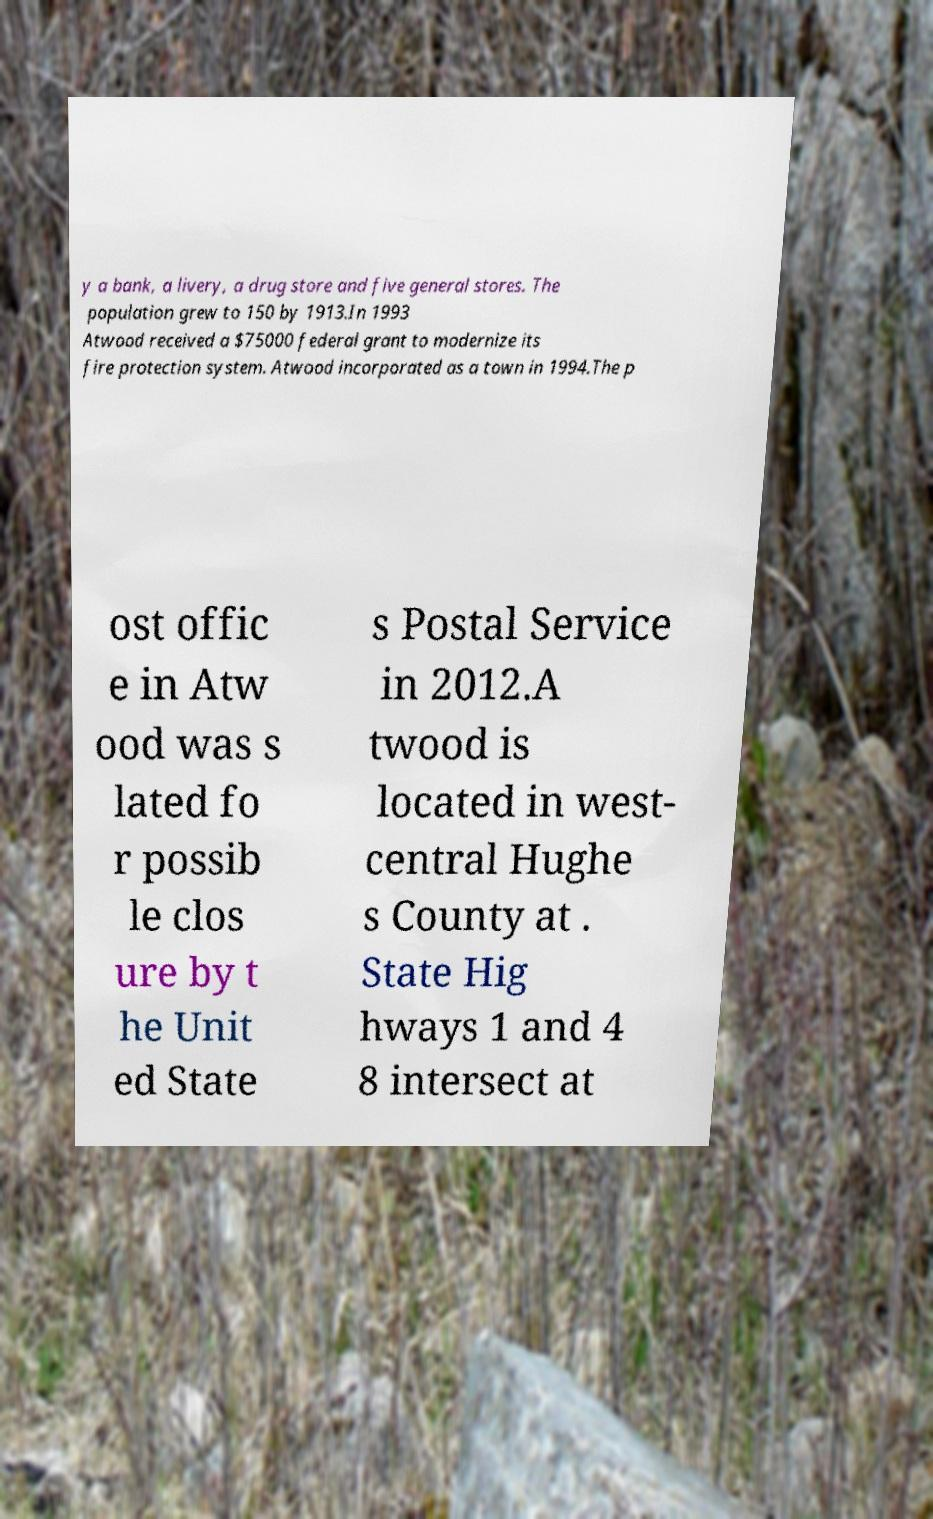Could you extract and type out the text from this image? y a bank, a livery, a drug store and five general stores. The population grew to 150 by 1913.In 1993 Atwood received a $75000 federal grant to modernize its fire protection system. Atwood incorporated as a town in 1994.The p ost offic e in Atw ood was s lated fo r possib le clos ure by t he Unit ed State s Postal Service in 2012.A twood is located in west- central Hughe s County at . State Hig hways 1 and 4 8 intersect at 